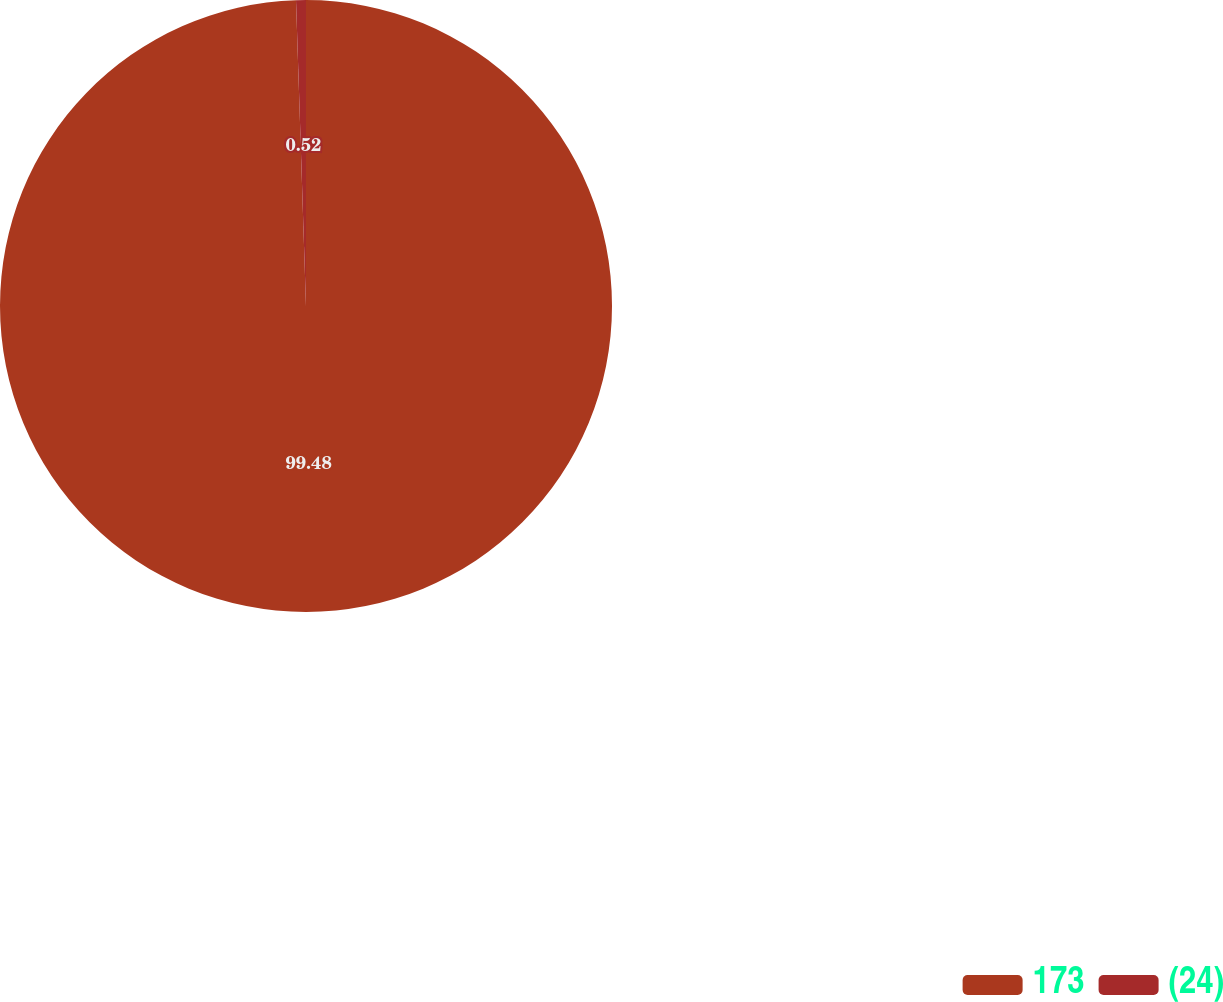Convert chart. <chart><loc_0><loc_0><loc_500><loc_500><pie_chart><fcel>173<fcel>(24)<nl><fcel>99.48%<fcel>0.52%<nl></chart> 